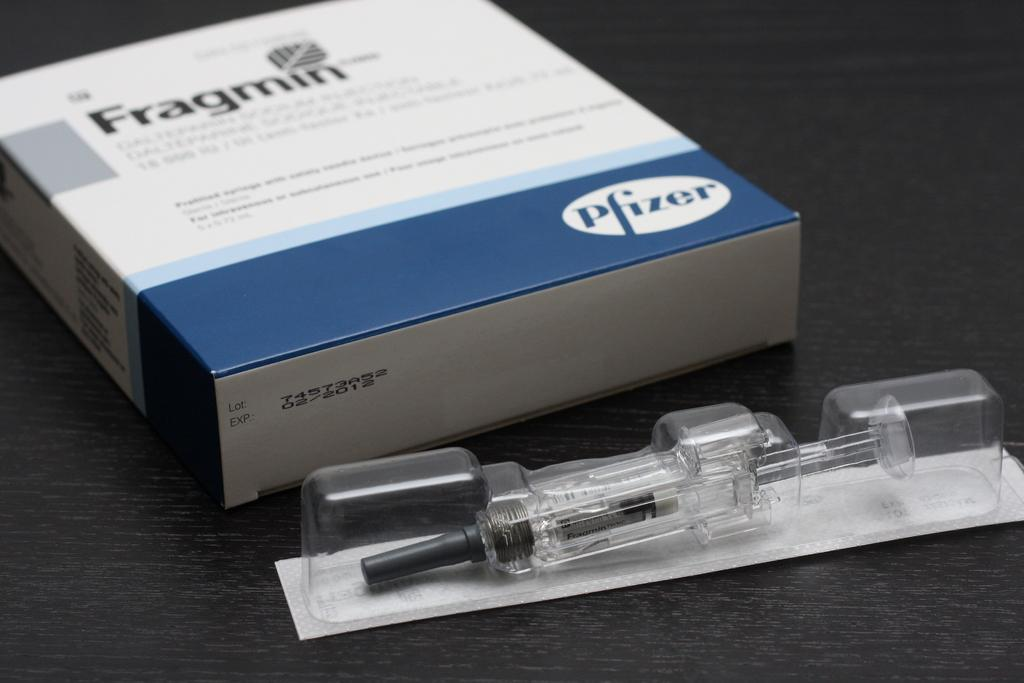<image>
Create a compact narrative representing the image presented. A syringe in front of a Fragmin box from Pfizer. 